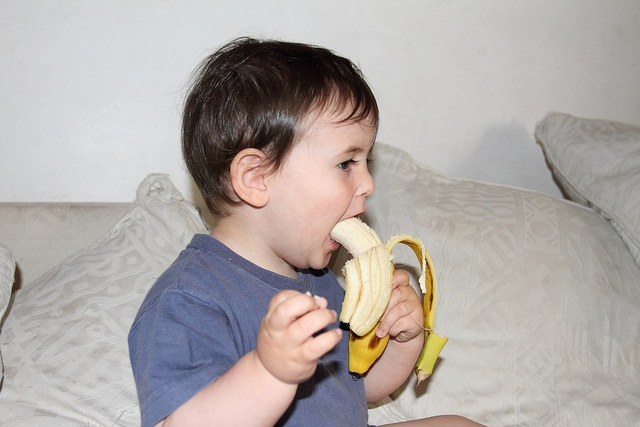Describe the objects in this image and their specific colors. I can see couch in lightgray and darkgray tones, bed in lightgray and darkgray tones, people in lightgray, gray, tan, and black tones, and banana in lightgray, beige, tan, orange, and khaki tones in this image. 